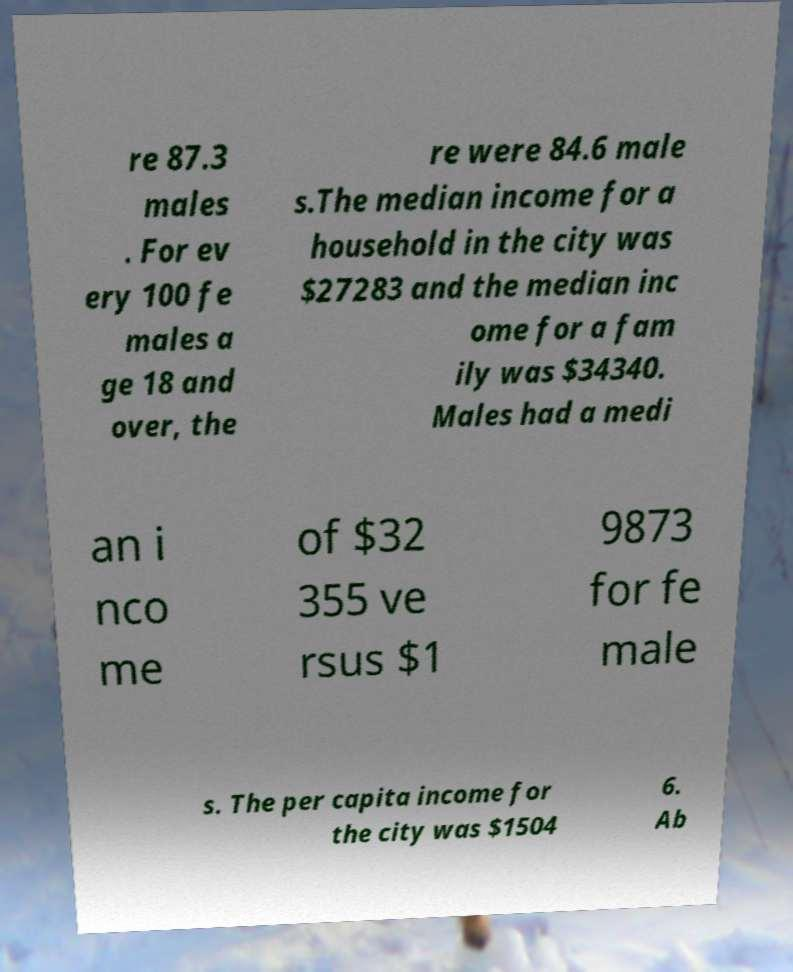Please read and relay the text visible in this image. What does it say? re 87.3 males . For ev ery 100 fe males a ge 18 and over, the re were 84.6 male s.The median income for a household in the city was $27283 and the median inc ome for a fam ily was $34340. Males had a medi an i nco me of $32 355 ve rsus $1 9873 for fe male s. The per capita income for the city was $1504 6. Ab 